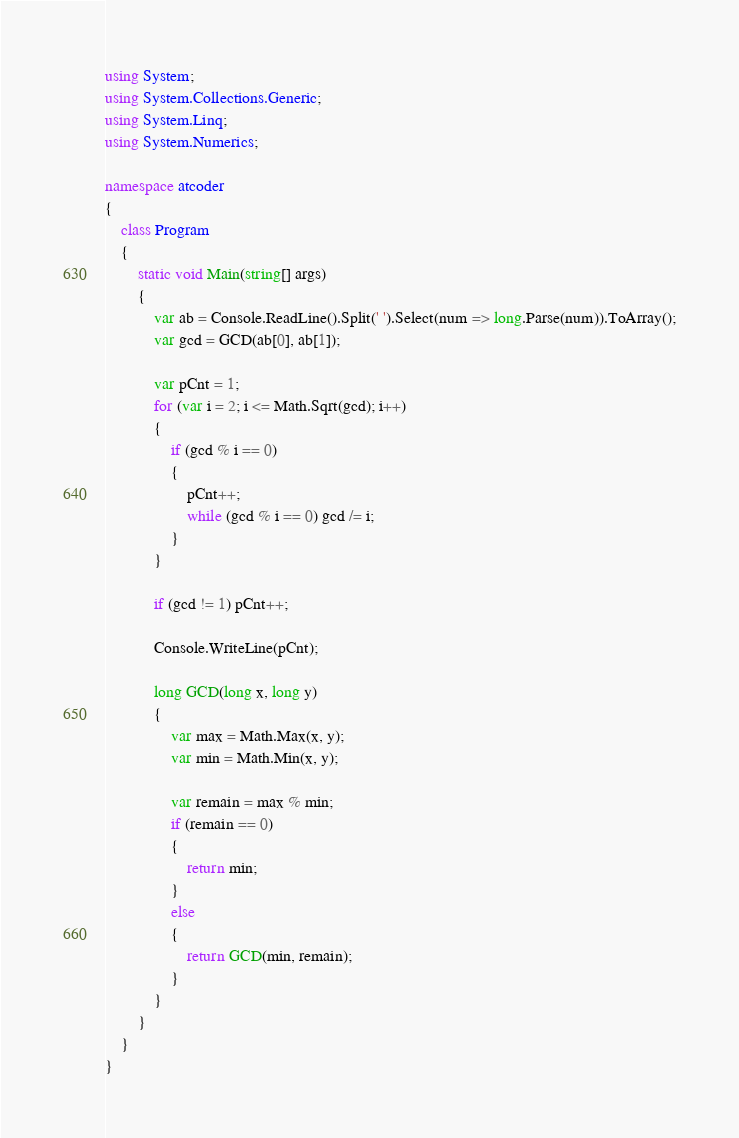Convert code to text. <code><loc_0><loc_0><loc_500><loc_500><_C#_>using System;
using System.Collections.Generic;
using System.Linq;
using System.Numerics;

namespace atcoder
{
    class Program
    {
        static void Main(string[] args)
        {
            var ab = Console.ReadLine().Split(' ').Select(num => long.Parse(num)).ToArray();
            var gcd = GCD(ab[0], ab[1]);

            var pCnt = 1;
            for (var i = 2; i <= Math.Sqrt(gcd); i++)
            {
                if (gcd % i == 0)
                {
                    pCnt++;
                    while (gcd % i == 0) gcd /= i;
                }
            }

            if (gcd != 1) pCnt++;

            Console.WriteLine(pCnt);

            long GCD(long x, long y)
            {
                var max = Math.Max(x, y);
                var min = Math.Min(x, y);

                var remain = max % min;
                if (remain == 0)
                {
                    return min;
                }
                else
                {
                    return GCD(min, remain);
                }
            }
        }
    }
}</code> 